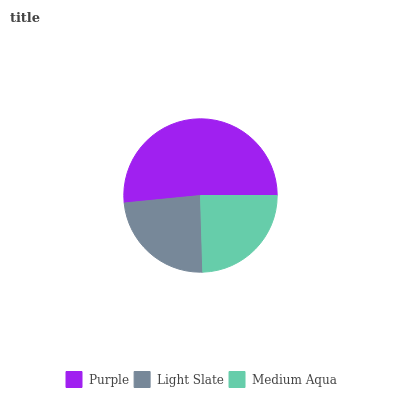Is Light Slate the minimum?
Answer yes or no. Yes. Is Purple the maximum?
Answer yes or no. Yes. Is Medium Aqua the minimum?
Answer yes or no. No. Is Medium Aqua the maximum?
Answer yes or no. No. Is Medium Aqua greater than Light Slate?
Answer yes or no. Yes. Is Light Slate less than Medium Aqua?
Answer yes or no. Yes. Is Light Slate greater than Medium Aqua?
Answer yes or no. No. Is Medium Aqua less than Light Slate?
Answer yes or no. No. Is Medium Aqua the high median?
Answer yes or no. Yes. Is Medium Aqua the low median?
Answer yes or no. Yes. Is Light Slate the high median?
Answer yes or no. No. Is Purple the low median?
Answer yes or no. No. 